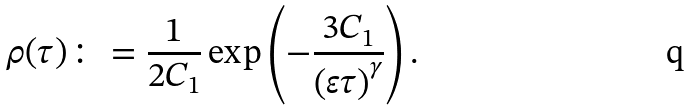<formula> <loc_0><loc_0><loc_500><loc_500>\rho ( \tau ) \colon = \frac { 1 } { 2 C _ { 1 } } \exp \left ( - \frac { 3 C _ { 1 } } { \left ( \varepsilon \tau \right ) ^ { \gamma } } \right ) .</formula> 